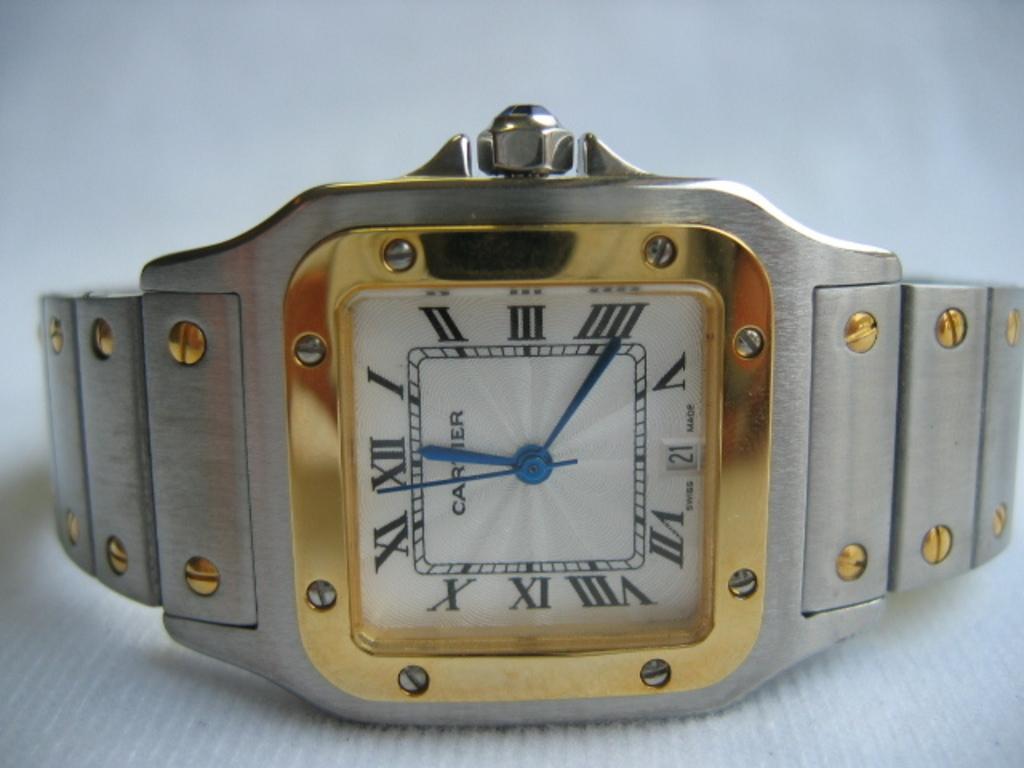What time is it?
Your answer should be very brief. 12:21. What is the date at the bottom of the watch?
Provide a short and direct response. 21. 